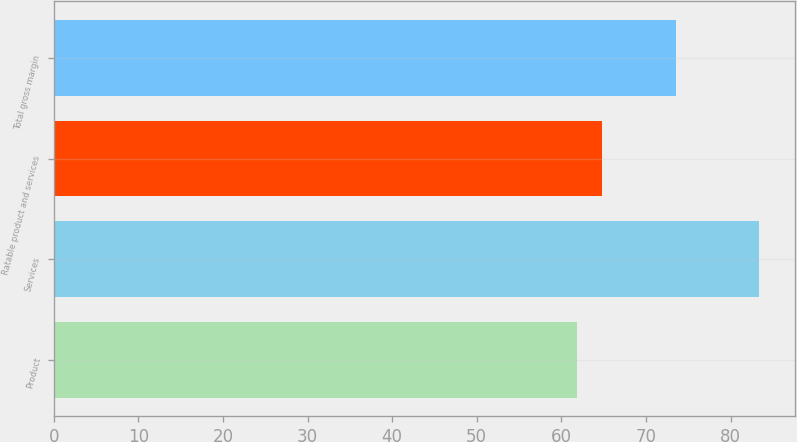Convert chart. <chart><loc_0><loc_0><loc_500><loc_500><bar_chart><fcel>Product<fcel>Services<fcel>Ratable product and services<fcel>Total gross margin<nl><fcel>61.9<fcel>83.4<fcel>64.8<fcel>73.6<nl></chart> 